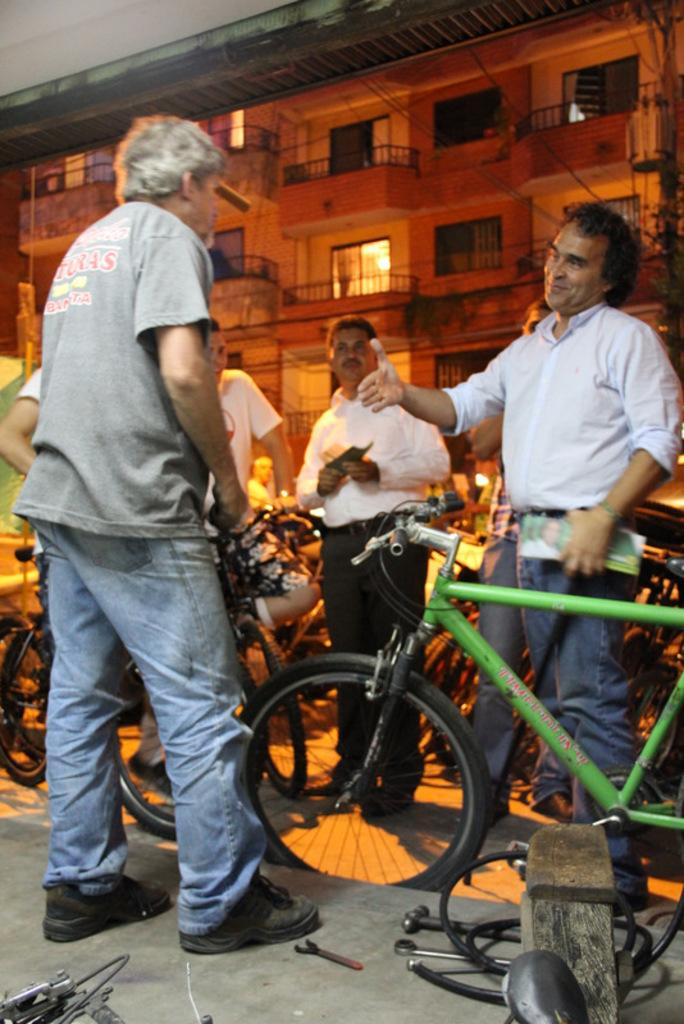How many men are present in the image? There are four men standing in the image. What objects can be seen alongside the men? There are bicycles in the image. What can be found on the floor in the image? There are tools on the floor in the image. What is visible in the background of the image? There is a building in the background of the image. How is the man on the right side of the image feeling? The man on the right side of the image is smiling. What type of chicken can be seen on the edge of the circle in the image? There is no chicken or circle present in the image. 